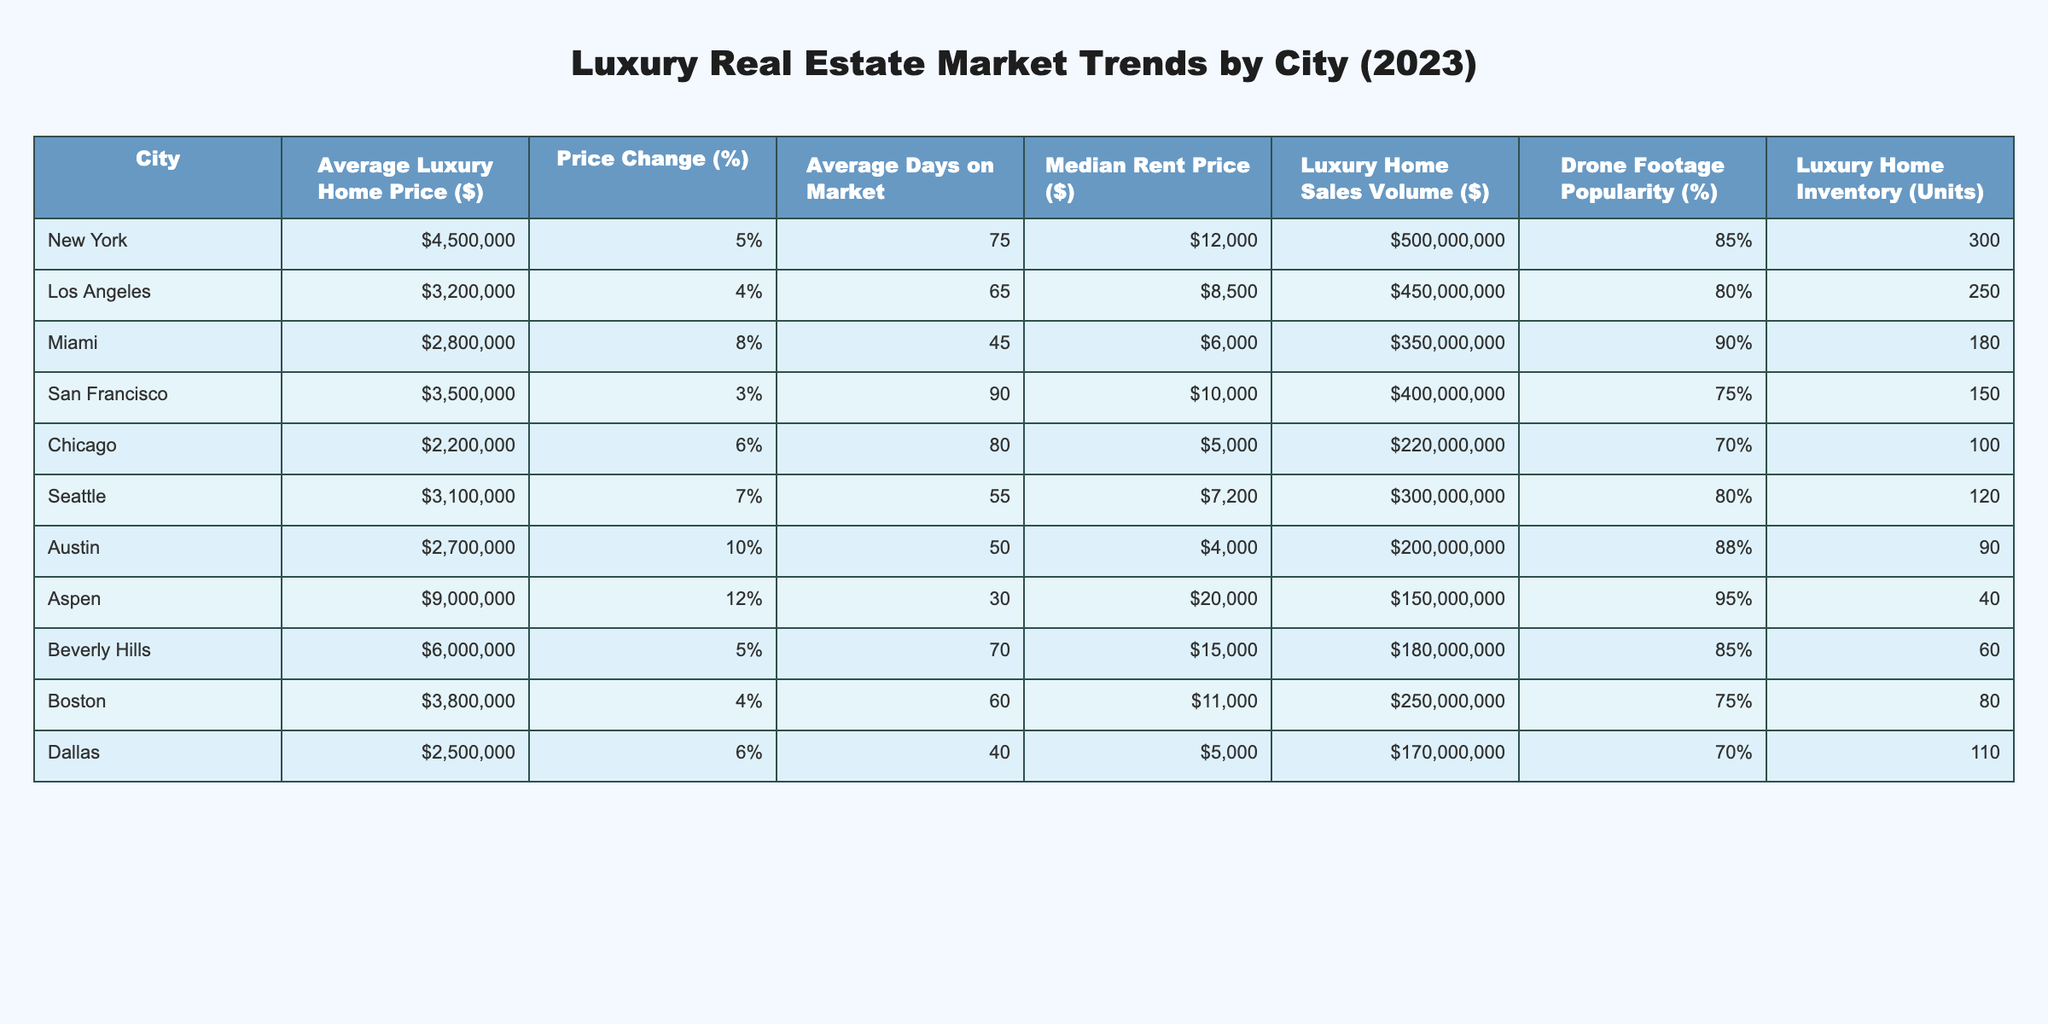What is the average luxury home price in Miami? According to the table, the average luxury home price for Miami is listed as $2,800,000.
Answer: $2,800,000 Which city has the highest drone footage popularity? The table shows that Aspen has the highest drone footage popularity at 95%.
Answer: 95% How much has the average luxury home price changed in Austin? In Austin, the price change is 10%, as indicated in the table.
Answer: 10% What is the total luxury home sales volume for New York and Los Angeles combined? The sales volume for New York is $500,000,000 and for Los Angeles is $450,000,000. Adding these together gives $500,000,000 + $450,000,000 = $950,000,000.
Answer: $950,000,000 Is the average days on the market for luxury homes shorter in Chicago than in Dallas? The table shows that Chicago has 80 days on market while Dallas has 40 days. Since 80 is greater than 40, this statement is false.
Answer: No Which city has the lowest median rent price? By comparing the median rent prices listed, Chicago has the lowest at $5,000.
Answer: $5,000 Calculate the average luxury home price of all the cities combined. To find the average luxury home price, first sum the prices: $4,500,000 + $3,200,000 + $2,800,000 + $3,500,000 + $2,200,000 + $3,100,000 + $2,700,000 + $9,000,000 + $6,000,000 + $3,800,000 + $2,500,000 = $44,500,000. Then divide by 11 cities: $44,500,000 / 11 = $4,045,454.55.
Answer: $4,045,454.55 Which city has the highest average days on the market? The table indicates San Francisco has the highest at 90 days on the market.
Answer: 90 days Is the luxury home inventory in Beverly Hills greater than that in Aspen? Beverly Hills has 60 units while Aspen has only 40 units. Since 60 is greater than 40, this statement is true.
Answer: Yes What is the price change percentage for the city with the lowest average luxury home price? Chicago has the lowest average luxury home price at $2,200,000, with a price change of 6%.
Answer: 6% How does the average rent price in Seattle compare to that in Miami? Seattle's median rent price is $7,200, while Miami’s is $6,000. Since $7,200 is greater than $6,000, average rent in Seattle is higher.
Answer: Higher 